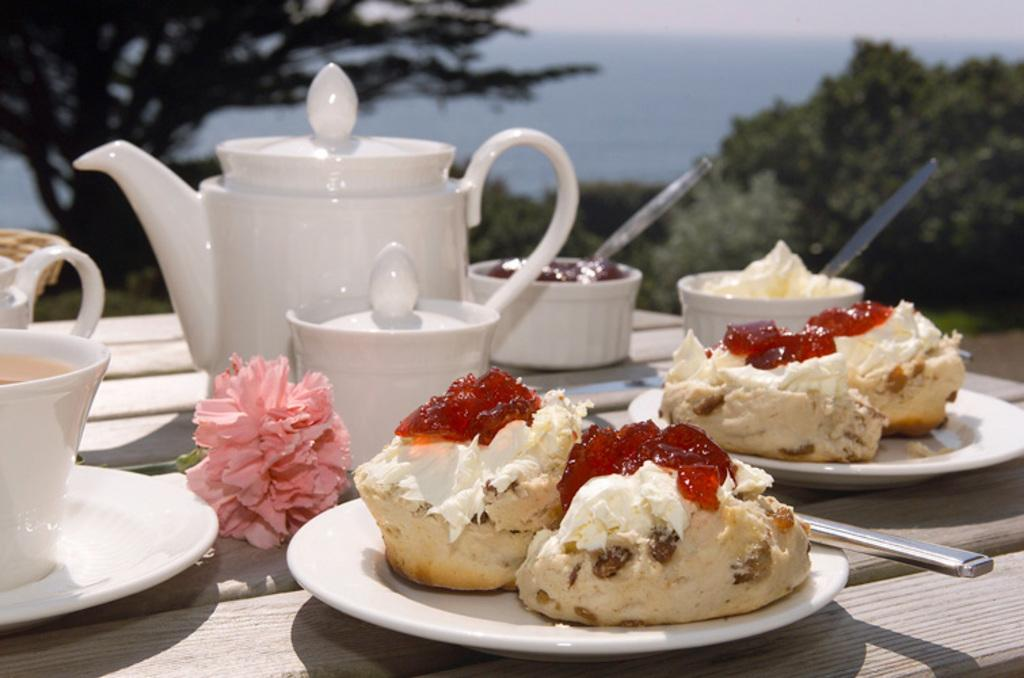What piece of furniture is present in the image? There is a table in the image. What items are placed on the table? There are plates, bowls, and cakes on the table. What can be seen in the background of the image? There are trees and the sky visible in the background of the image. Who is the manager of the authority in the image? There is no mention of an authority, manager, or any related concepts in the image. 